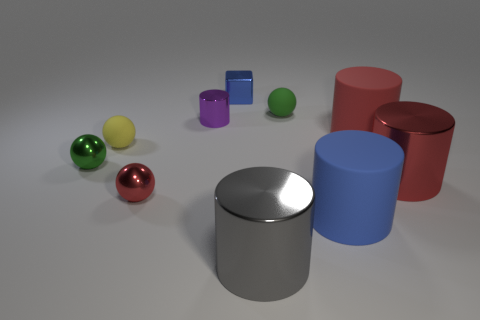Subtract all blue rubber cylinders. How many cylinders are left? 4 Subtract all cyan spheres. How many red cylinders are left? 2 Subtract all purple cylinders. How many cylinders are left? 4 Subtract 1 cubes. How many cubes are left? 0 Subtract all balls. How many objects are left? 6 Subtract all brown blocks. Subtract all yellow balls. How many blocks are left? 1 Subtract all big objects. Subtract all large blue matte balls. How many objects are left? 6 Add 1 gray metal cylinders. How many gray metal cylinders are left? 2 Add 7 blue balls. How many blue balls exist? 7 Subtract 0 green cubes. How many objects are left? 10 